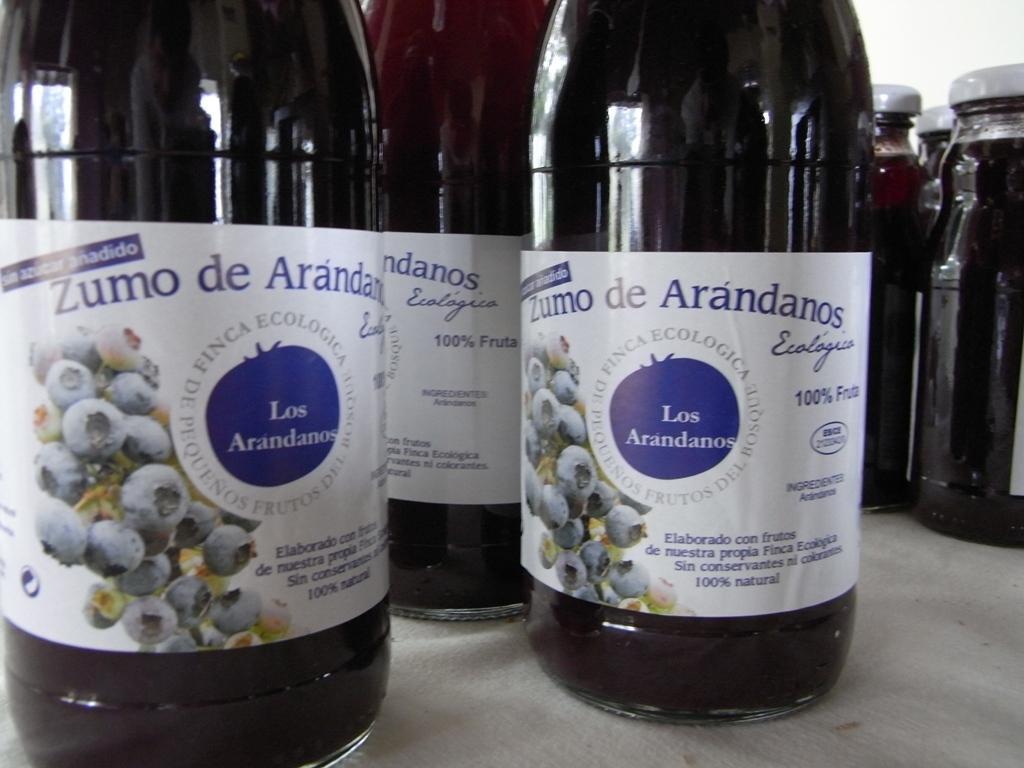Could you give a brief overview of what you see in this image? In this picture I can see there are some jars here and they are placed on the grey surface and they are labelled and sealed. There is a white wall in the backdrop. 